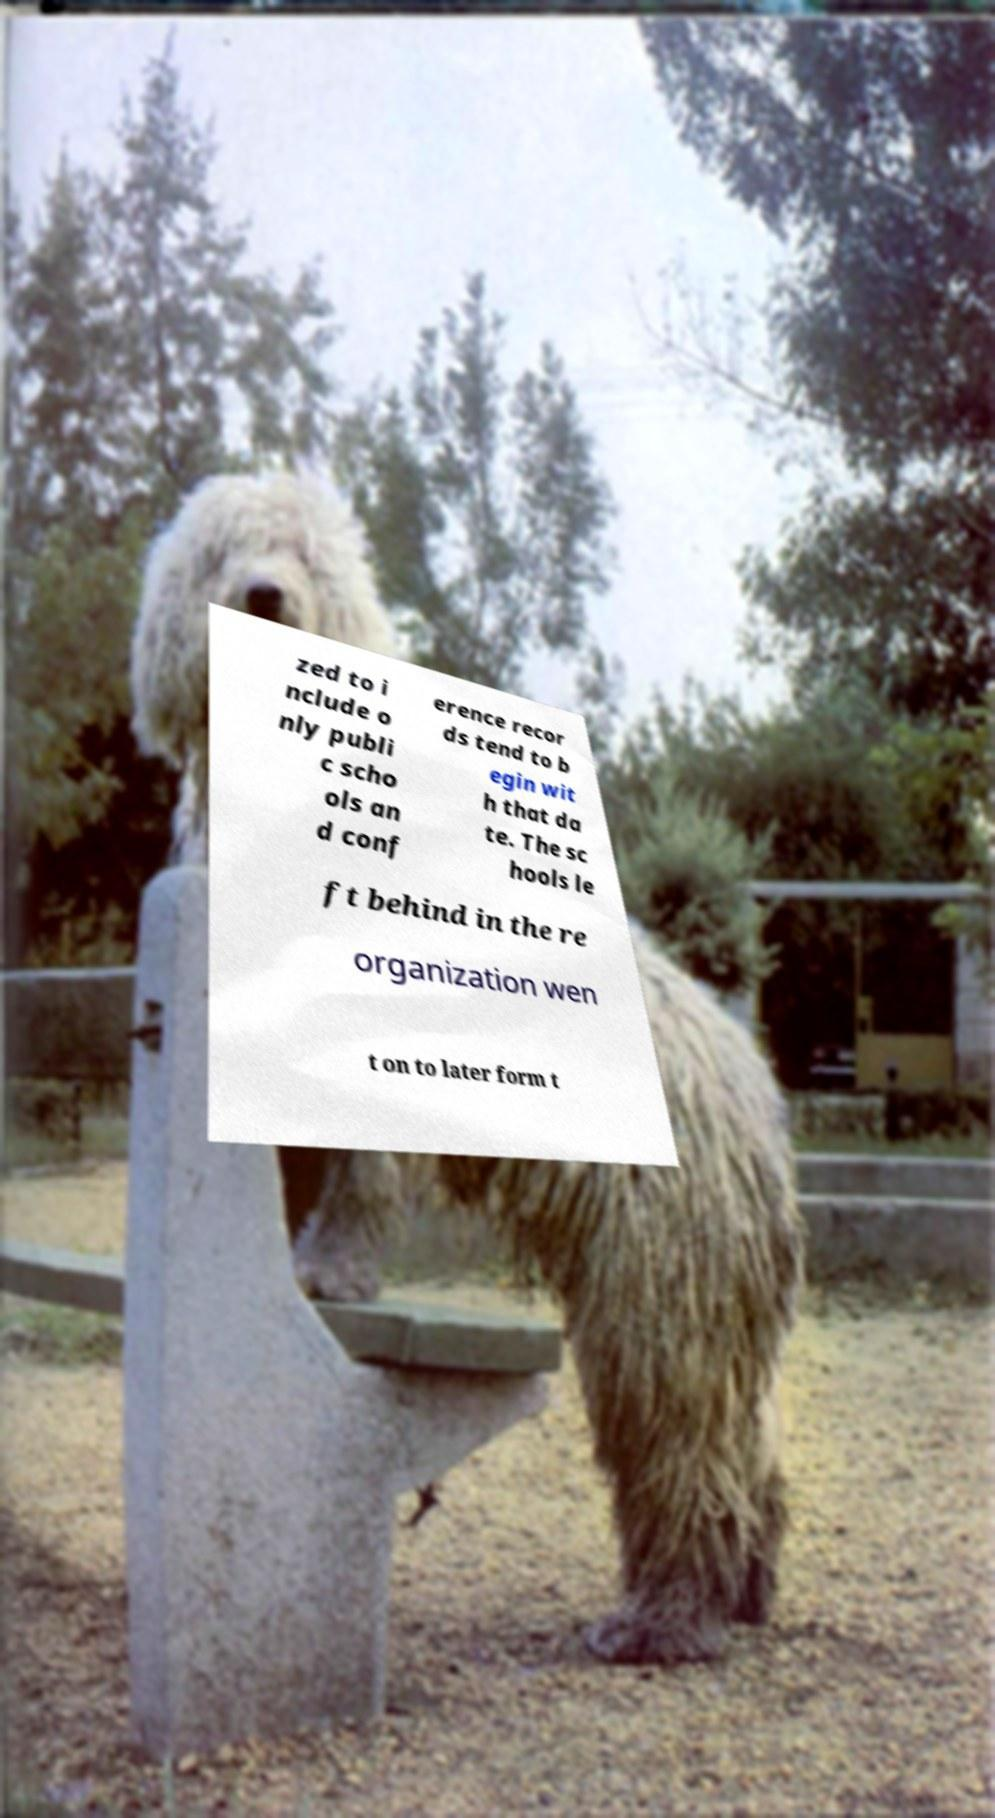There's text embedded in this image that I need extracted. Can you transcribe it verbatim? zed to i nclude o nly publi c scho ols an d conf erence recor ds tend to b egin wit h that da te. The sc hools le ft behind in the re organization wen t on to later form t 